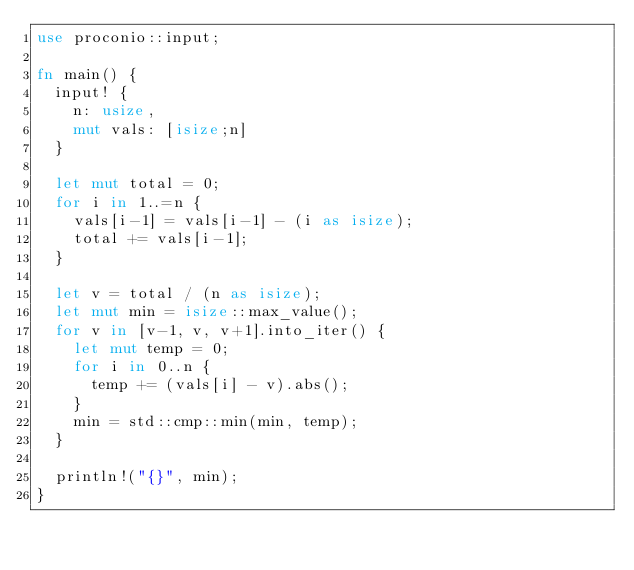Convert code to text. <code><loc_0><loc_0><loc_500><loc_500><_Rust_>use proconio::input;
 
fn main() {
  input! {
    n: usize,
    mut vals: [isize;n]
  }
  
  let mut total = 0;
  for i in 1..=n {
    vals[i-1] = vals[i-1] - (i as isize);
    total += vals[i-1];
  }
  
  let v = total / (n as isize);
  let mut min = isize::max_value();
  for v in [v-1, v, v+1].into_iter() {
    let mut temp = 0;
    for i in 0..n {
      temp += (vals[i] - v).abs();
    }
    min = std::cmp::min(min, temp);
  }
  
  println!("{}", min);
}</code> 